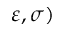Convert formula to latex. <formula><loc_0><loc_0><loc_500><loc_500>\varepsilon , \sigma )</formula> 